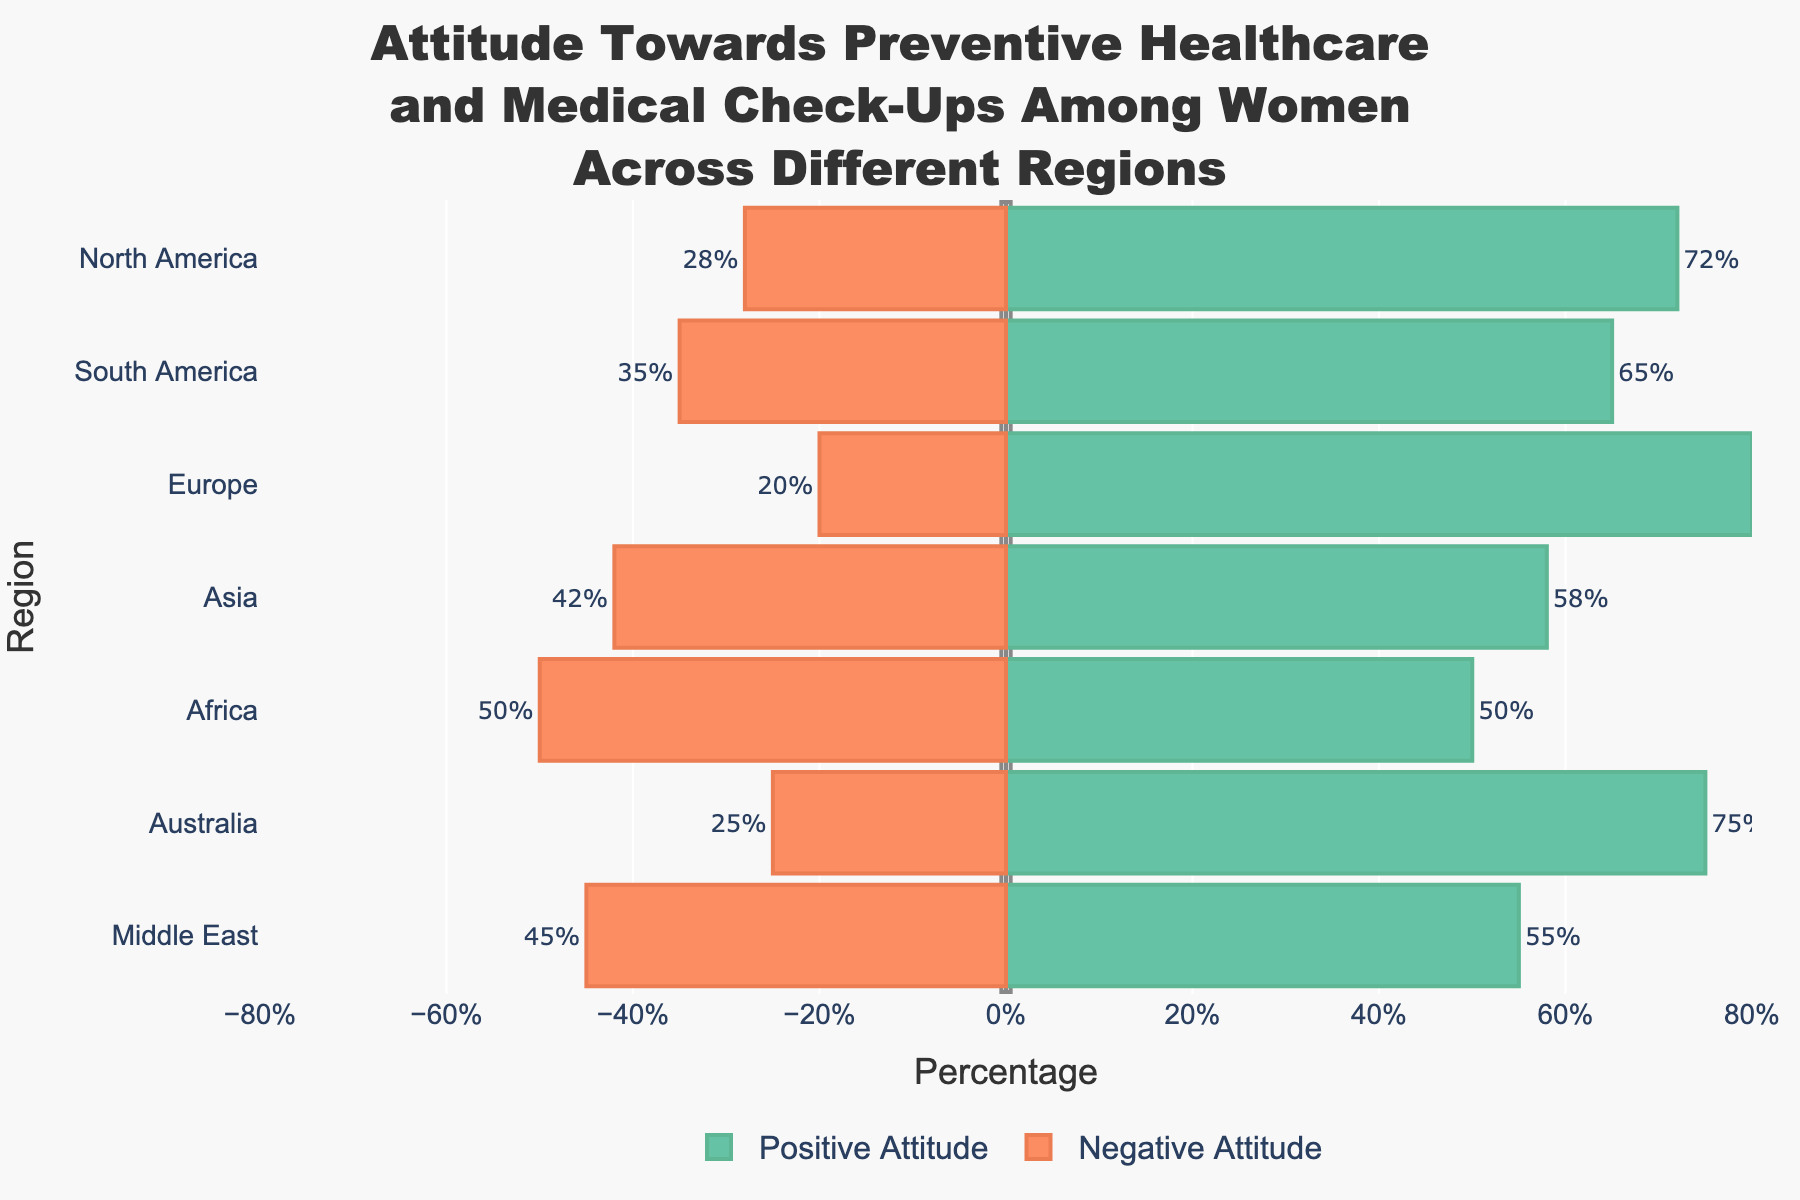What's the region with the highest positive attitude towards preventive healthcare? The region with the highest positive attitude is determined by identifying the bar with the longest extent to the right. Europe has the longest bar extending to 80%, indicating the highest positive attitude.
Answer: Europe What's the total percentage difference between the positive and negative attitudes in Asia? To find the total percentage difference, subtract the negative attitude from the positive attitude. For Asia, the difference is 58% - 42% = 16%.
Answer: 16% Which region shows an equal percentage of positive and negative attitudes towards preventive healthcare? The region with equal positive and negative attitudes is represented by bars of equal length, one extending to the right and the other to the left by the same percentage. Africa's bars both extend to 50%, indicating equality.
Answer: Africa By how many percentage points is the positive attitude in North America higher than the negative attitude in the Middle East? Subtract the negative attitude percentage of the Middle East from the positive attitude percentage of North America. North America has 72% positive, and the Middle East has 45% negative; the difference is 72% - 45% = 27 percentage points.
Answer: 27 percentage points Which region has the smallest positive attitude towards preventive healthcare? Identify the region with the shortest bar extending to the right, which corresponds to the positive attitude percentage. Africa has the shortest positive attitude bar at 50%.
Answer: Africa What's the average positive attitude percentage across all regions? Add all the positive attitude percentages and divide by the number of regions. (72% + 65% + 80% + 58% + 50% + 75% + 55%) / 7 = 65%.
Answer: 65% How does the negative attitude in South America compare with that in Australia? Compare the extents of the bars extending to the left for South America and Australia. South America has 35% negative and Australia has 25% negative, so South America's negative attitude is higher by 10%.
Answer: South America's negative attitude is higher by 10% By what factor is the positive attitude in Europe greater than the negative attitude in Europe? Divide the positive attitude percentage by the negative attitude percentage for Europe. The calculation is 80% / 20% = 4.
Answer: 4 What is the median positive attitude percentage? To find the median, arrange the percentages in ascending order and find the middle value. The values are 50%, 55%, 58%, 65%, 72%, 75%, 80%. The median is 65%.
Answer: 65% Which regions have a negative attitude percentage of 40% or more? Identify the regions with bars extending to the left by 40% or more. Asia has 42%, Africa has 50%, and the Middle East has 45%.
Answer: Asia, Africa, and the Middle East 